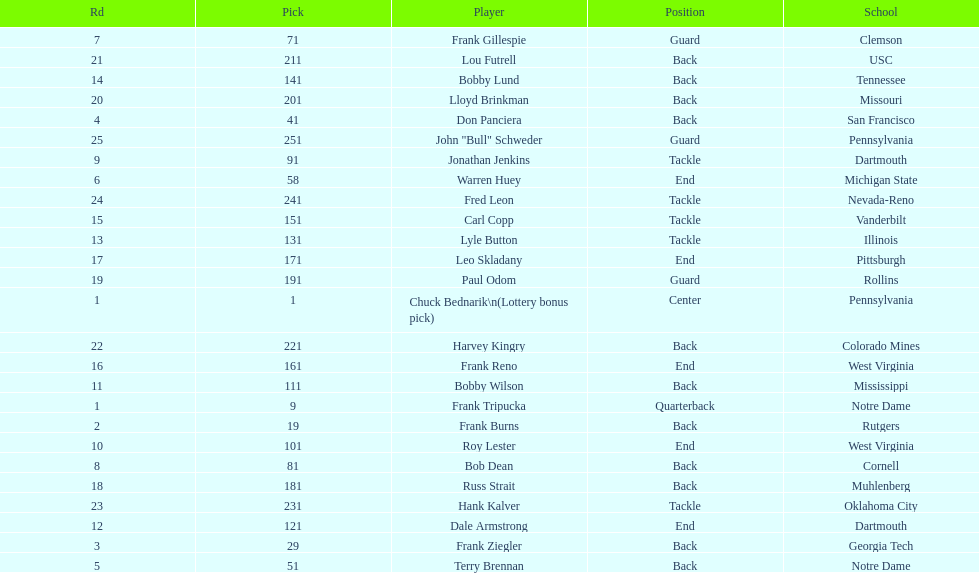What was the position that most of the players had? Back. 